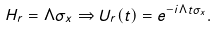Convert formula to latex. <formula><loc_0><loc_0><loc_500><loc_500>H _ { r } = \Lambda \sigma _ { x } \Rightarrow U _ { r } ( t ) = e ^ { - i \Lambda t \sigma _ { x } } .</formula> 